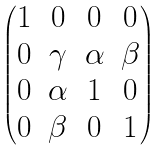Convert formula to latex. <formula><loc_0><loc_0><loc_500><loc_500>\begin{pmatrix} 1 & 0 & 0 & 0 \\ 0 & \gamma & \alpha & \beta \\ 0 & \alpha & 1 & 0 \\ 0 & \beta & 0 & 1 \end{pmatrix}</formula> 